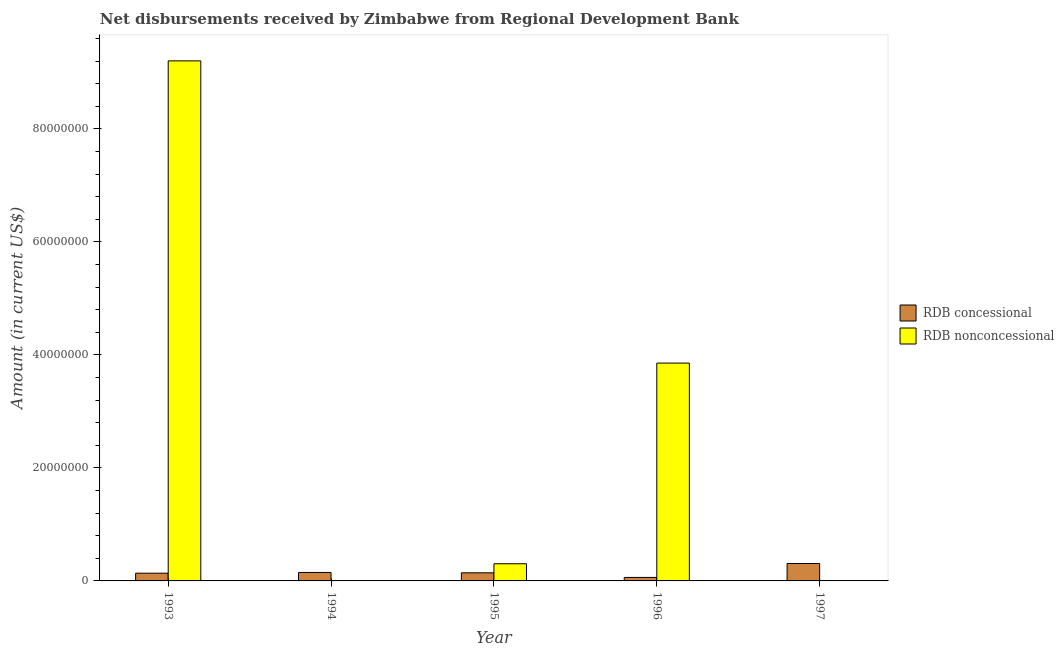Are the number of bars per tick equal to the number of legend labels?
Offer a terse response. No. What is the label of the 1st group of bars from the left?
Your response must be concise. 1993. In how many cases, is the number of bars for a given year not equal to the number of legend labels?
Ensure brevity in your answer.  2. What is the net concessional disbursements from rdb in 1995?
Offer a very short reply. 1.43e+06. Across all years, what is the maximum net non concessional disbursements from rdb?
Ensure brevity in your answer.  9.20e+07. In which year was the net non concessional disbursements from rdb maximum?
Offer a very short reply. 1993. What is the total net non concessional disbursements from rdb in the graph?
Make the answer very short. 1.34e+08. What is the difference between the net concessional disbursements from rdb in 1993 and that in 1997?
Your response must be concise. -1.72e+06. What is the difference between the net non concessional disbursements from rdb in 1997 and the net concessional disbursements from rdb in 1994?
Your answer should be very brief. 0. What is the average net non concessional disbursements from rdb per year?
Your answer should be very brief. 2.67e+07. In how many years, is the net non concessional disbursements from rdb greater than 72000000 US$?
Offer a terse response. 1. What is the ratio of the net concessional disbursements from rdb in 1995 to that in 1997?
Provide a succinct answer. 0.46. Is the difference between the net non concessional disbursements from rdb in 1995 and 1996 greater than the difference between the net concessional disbursements from rdb in 1995 and 1996?
Provide a short and direct response. No. What is the difference between the highest and the second highest net concessional disbursements from rdb?
Your answer should be compact. 1.59e+06. What is the difference between the highest and the lowest net concessional disbursements from rdb?
Your answer should be compact. 2.47e+06. Are all the bars in the graph horizontal?
Keep it short and to the point. No. What is the difference between two consecutive major ticks on the Y-axis?
Ensure brevity in your answer.  2.00e+07. Are the values on the major ticks of Y-axis written in scientific E-notation?
Offer a very short reply. No. Does the graph contain any zero values?
Provide a short and direct response. Yes. Does the graph contain grids?
Offer a terse response. No. How are the legend labels stacked?
Your answer should be very brief. Vertical. What is the title of the graph?
Provide a short and direct response. Net disbursements received by Zimbabwe from Regional Development Bank. Does "Passenger Transport Items" appear as one of the legend labels in the graph?
Give a very brief answer. No. What is the label or title of the X-axis?
Give a very brief answer. Year. What is the label or title of the Y-axis?
Give a very brief answer. Amount (in current US$). What is the Amount (in current US$) of RDB concessional in 1993?
Give a very brief answer. 1.37e+06. What is the Amount (in current US$) in RDB nonconcessional in 1993?
Provide a succinct answer. 9.20e+07. What is the Amount (in current US$) of RDB concessional in 1994?
Ensure brevity in your answer.  1.50e+06. What is the Amount (in current US$) in RDB concessional in 1995?
Offer a very short reply. 1.43e+06. What is the Amount (in current US$) of RDB nonconcessional in 1995?
Provide a short and direct response. 3.04e+06. What is the Amount (in current US$) of RDB concessional in 1996?
Keep it short and to the point. 6.17e+05. What is the Amount (in current US$) in RDB nonconcessional in 1996?
Offer a terse response. 3.86e+07. What is the Amount (in current US$) of RDB concessional in 1997?
Your answer should be very brief. 3.08e+06. Across all years, what is the maximum Amount (in current US$) in RDB concessional?
Your answer should be very brief. 3.08e+06. Across all years, what is the maximum Amount (in current US$) of RDB nonconcessional?
Make the answer very short. 9.20e+07. Across all years, what is the minimum Amount (in current US$) in RDB concessional?
Provide a short and direct response. 6.17e+05. What is the total Amount (in current US$) in RDB concessional in the graph?
Offer a terse response. 8.00e+06. What is the total Amount (in current US$) in RDB nonconcessional in the graph?
Make the answer very short. 1.34e+08. What is the difference between the Amount (in current US$) in RDB concessional in 1993 and that in 1994?
Make the answer very short. -1.27e+05. What is the difference between the Amount (in current US$) of RDB concessional in 1993 and that in 1995?
Keep it short and to the point. -6.50e+04. What is the difference between the Amount (in current US$) of RDB nonconcessional in 1993 and that in 1995?
Offer a terse response. 8.90e+07. What is the difference between the Amount (in current US$) in RDB concessional in 1993 and that in 1996?
Your response must be concise. 7.52e+05. What is the difference between the Amount (in current US$) of RDB nonconcessional in 1993 and that in 1996?
Ensure brevity in your answer.  5.35e+07. What is the difference between the Amount (in current US$) in RDB concessional in 1993 and that in 1997?
Offer a very short reply. -1.72e+06. What is the difference between the Amount (in current US$) of RDB concessional in 1994 and that in 1995?
Make the answer very short. 6.20e+04. What is the difference between the Amount (in current US$) of RDB concessional in 1994 and that in 1996?
Ensure brevity in your answer.  8.79e+05. What is the difference between the Amount (in current US$) of RDB concessional in 1994 and that in 1997?
Make the answer very short. -1.59e+06. What is the difference between the Amount (in current US$) of RDB concessional in 1995 and that in 1996?
Give a very brief answer. 8.17e+05. What is the difference between the Amount (in current US$) in RDB nonconcessional in 1995 and that in 1996?
Give a very brief answer. -3.55e+07. What is the difference between the Amount (in current US$) in RDB concessional in 1995 and that in 1997?
Your response must be concise. -1.65e+06. What is the difference between the Amount (in current US$) in RDB concessional in 1996 and that in 1997?
Give a very brief answer. -2.47e+06. What is the difference between the Amount (in current US$) in RDB concessional in 1993 and the Amount (in current US$) in RDB nonconcessional in 1995?
Provide a succinct answer. -1.67e+06. What is the difference between the Amount (in current US$) of RDB concessional in 1993 and the Amount (in current US$) of RDB nonconcessional in 1996?
Your answer should be very brief. -3.72e+07. What is the difference between the Amount (in current US$) in RDB concessional in 1994 and the Amount (in current US$) in RDB nonconcessional in 1995?
Your answer should be compact. -1.54e+06. What is the difference between the Amount (in current US$) in RDB concessional in 1994 and the Amount (in current US$) in RDB nonconcessional in 1996?
Make the answer very short. -3.71e+07. What is the difference between the Amount (in current US$) of RDB concessional in 1995 and the Amount (in current US$) of RDB nonconcessional in 1996?
Give a very brief answer. -3.71e+07. What is the average Amount (in current US$) of RDB concessional per year?
Offer a very short reply. 1.60e+06. What is the average Amount (in current US$) in RDB nonconcessional per year?
Keep it short and to the point. 2.67e+07. In the year 1993, what is the difference between the Amount (in current US$) of RDB concessional and Amount (in current US$) of RDB nonconcessional?
Give a very brief answer. -9.07e+07. In the year 1995, what is the difference between the Amount (in current US$) in RDB concessional and Amount (in current US$) in RDB nonconcessional?
Offer a terse response. -1.60e+06. In the year 1996, what is the difference between the Amount (in current US$) in RDB concessional and Amount (in current US$) in RDB nonconcessional?
Your response must be concise. -3.79e+07. What is the ratio of the Amount (in current US$) of RDB concessional in 1993 to that in 1994?
Give a very brief answer. 0.92. What is the ratio of the Amount (in current US$) of RDB concessional in 1993 to that in 1995?
Give a very brief answer. 0.95. What is the ratio of the Amount (in current US$) of RDB nonconcessional in 1993 to that in 1995?
Your answer should be very brief. 30.3. What is the ratio of the Amount (in current US$) in RDB concessional in 1993 to that in 1996?
Your answer should be very brief. 2.22. What is the ratio of the Amount (in current US$) in RDB nonconcessional in 1993 to that in 1996?
Keep it short and to the point. 2.39. What is the ratio of the Amount (in current US$) of RDB concessional in 1993 to that in 1997?
Your answer should be compact. 0.44. What is the ratio of the Amount (in current US$) of RDB concessional in 1994 to that in 1995?
Provide a short and direct response. 1.04. What is the ratio of the Amount (in current US$) of RDB concessional in 1994 to that in 1996?
Keep it short and to the point. 2.42. What is the ratio of the Amount (in current US$) of RDB concessional in 1994 to that in 1997?
Offer a very short reply. 0.48. What is the ratio of the Amount (in current US$) of RDB concessional in 1995 to that in 1996?
Keep it short and to the point. 2.32. What is the ratio of the Amount (in current US$) in RDB nonconcessional in 1995 to that in 1996?
Give a very brief answer. 0.08. What is the ratio of the Amount (in current US$) in RDB concessional in 1995 to that in 1997?
Offer a terse response. 0.46. What is the ratio of the Amount (in current US$) of RDB concessional in 1996 to that in 1997?
Provide a succinct answer. 0.2. What is the difference between the highest and the second highest Amount (in current US$) in RDB concessional?
Offer a terse response. 1.59e+06. What is the difference between the highest and the second highest Amount (in current US$) in RDB nonconcessional?
Your answer should be compact. 5.35e+07. What is the difference between the highest and the lowest Amount (in current US$) of RDB concessional?
Make the answer very short. 2.47e+06. What is the difference between the highest and the lowest Amount (in current US$) of RDB nonconcessional?
Offer a terse response. 9.20e+07. 